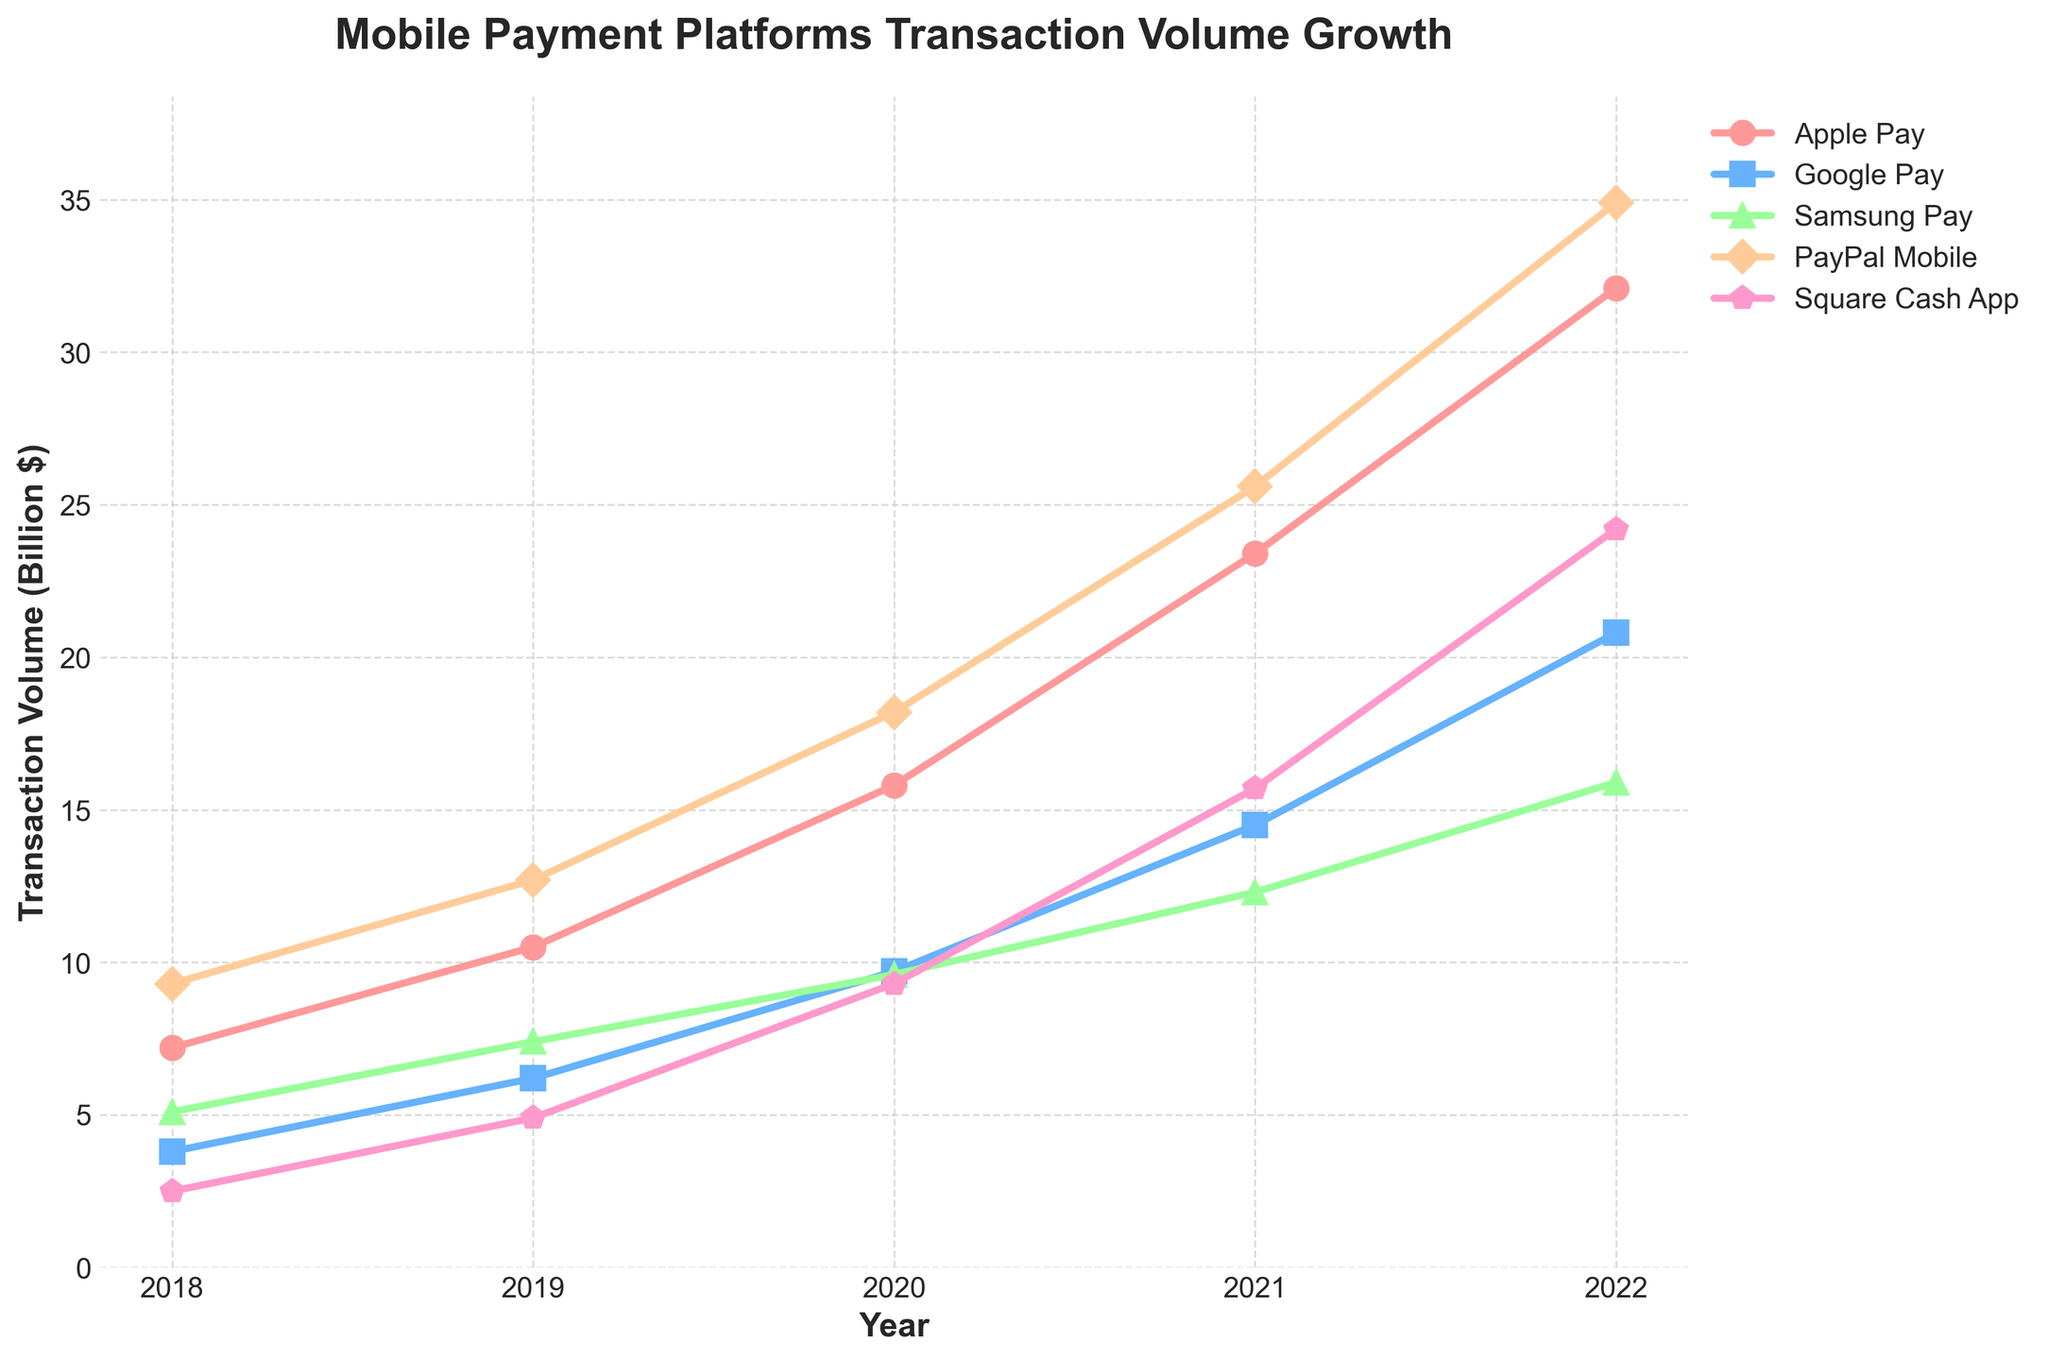What's the overall trend for the transaction volume growth for Apple Pay from 2018 to 2022? Looking at the line representing Apple Pay, it consistently rises each year. Starting from 7.2 in 2018, it increases to 32.1 in 2022, indicating that Apple Pay's transaction volume has been steadily growing over the 5-year period.
Answer: Steadily increasing How does the 2022 transaction volume of PayPal Mobile compare to the volume in 2018? In 2018, PayPal Mobile's transaction volume was 9.3 billion dollars. By 2022, it grew to 34.9 billion dollars. So, the transaction volume increased significantly over the 5-year period.
Answer: Increased significantly Which payment platform had the highest transaction volume in 2022? By looking at the data points for 2022, PayPal Mobile had the highest transaction volume at 34.9 billion dollars.
Answer: PayPal Mobile What is the difference in transaction volume between Google Pay and Samsung Pay in 2021? In 2021, Google Pay's transaction volume was 14.5 billion dollars and Samsung Pay's was 12.3 billion dollars. The difference is 14.5 - 12.3 = 2.2 billion dollars.
Answer: 2.2 billion dollars Which platform had the lowest transaction volume in 2018 and how much was it? Observing the 2018 data points, Square Cash App had the lowest transaction volume at 2.5 billion dollars.
Answer: Square Cash App, 2.5 billion dollars Compare the volume growth of Google Pay and Square Cash App from 2019 to 2020. Which one grew more, and by how much? From 2019 to 2020, Google Pay's volume increased from 6.2 to 9.7 billion dollars (growth of 3.5 billion dollars), whereas Square Cash App's volume increased from 4.9 to 9.3 billion dollars (growth of 4.4 billion dollars). Square Cash App grew more.
Answer: Square Cash App, 0.9 billion dollars more What is the average transaction volume for Samsung Pay over the given years? Summing the volumes for Samsung Pay from 2018 to 2022: 5.1 + 7.4 + 9.6 + 12.3 + 15.9 = 50.3 billion dollars. There are 5 years, so the average is 50.3 / 5 = 10.06 billion dollars.
Answer: 10.06 billion dollars Which platform experienced the greatest increase in transaction volume between 2020 and 2021? Between 2020 and 2021, the changes in transaction volumes were: Apple Pay (23.4 - 15.8 = 7.6 billion), Google Pay (14.5 - 9.7 = 4.8 billion), Samsung Pay (12.3 - 9.6 = 2.7 billion), PayPal Mobile (25.6 - 18.2 = 7.4 billion), Square Cash App (15.7 - 9.3 = 6.4 billion). Apple Pay had the greatest increase of 7.6 billion.
Answer: Apple Pay What's the combined transaction volume of all platforms in 2018? Summing all the transaction volumes for the year 2018: 7.2 + 3.8 + 5.1 + 9.3 + 2.5 = 27.9 billion dollars.
Answer: 27.9 billion dollars 